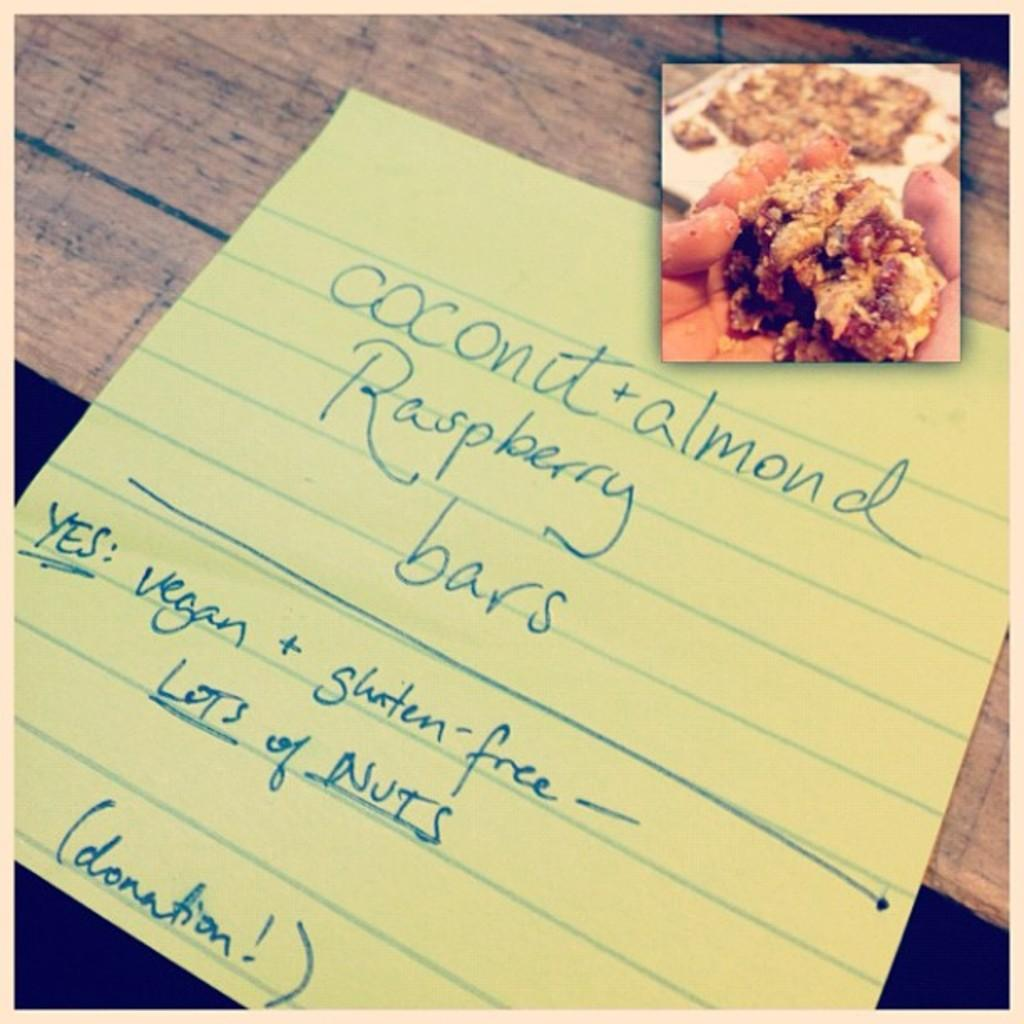<image>
Summarize the visual content of the image. The handwritten note states that the coconut & almond raspberry bars are vegan and gluten free. 